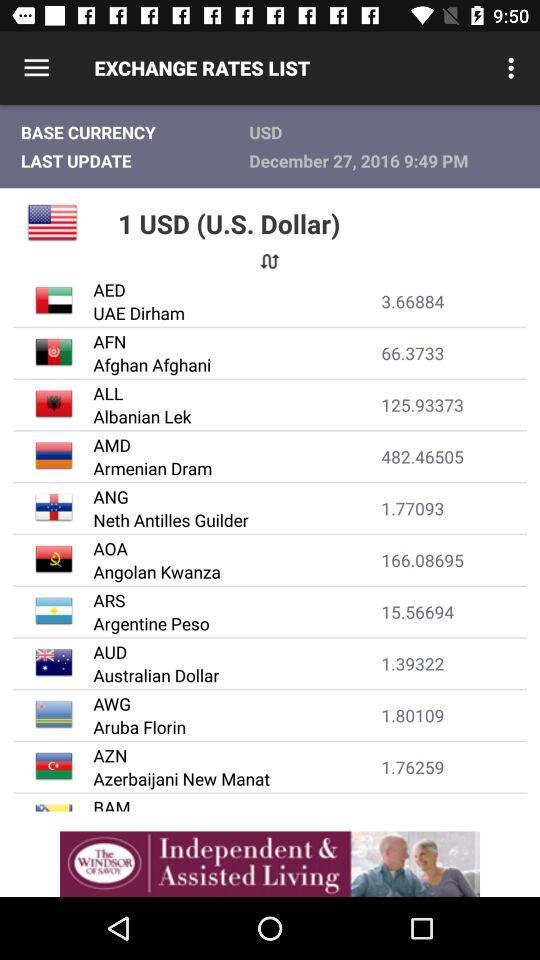What is the currency of Argentina? The currency of Argentina is the Argentine Peso. 